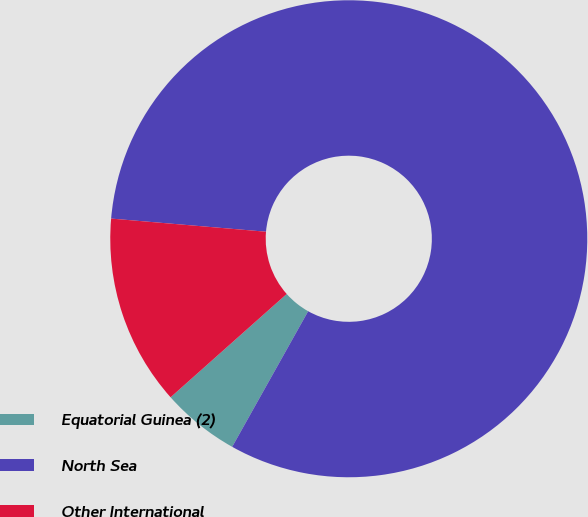<chart> <loc_0><loc_0><loc_500><loc_500><pie_chart><fcel>Equatorial Guinea (2)<fcel>North Sea<fcel>Other International<nl><fcel>5.3%<fcel>81.78%<fcel>12.92%<nl></chart> 